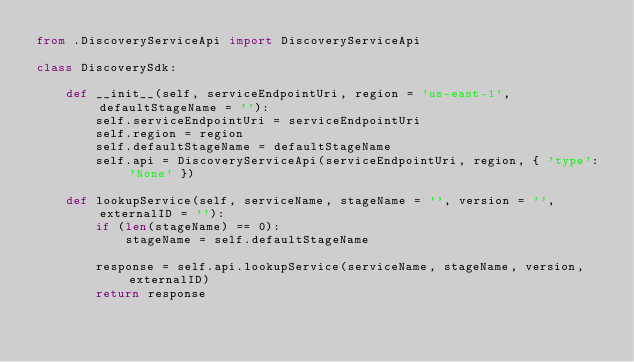<code> <loc_0><loc_0><loc_500><loc_500><_Python_>from .DiscoveryServiceApi import DiscoveryServiceApi

class DiscoverySdk:

    def __init__(self, serviceEndpointUri, region = 'us-east-1', defaultStageName = ''):
        self.serviceEndpointUri = serviceEndpointUri
        self.region = region
        self.defaultStageName = defaultStageName
        self.api = DiscoveryServiceApi(serviceEndpointUri, region, { 'type': 'None' })

    def lookupService(self, serviceName, stageName = '', version = '', externalID = ''):
        if (len(stageName) == 0):
            stageName = self.defaultStageName

        response = self.api.lookupService(serviceName, stageName, version, externalID)
        return response
</code> 